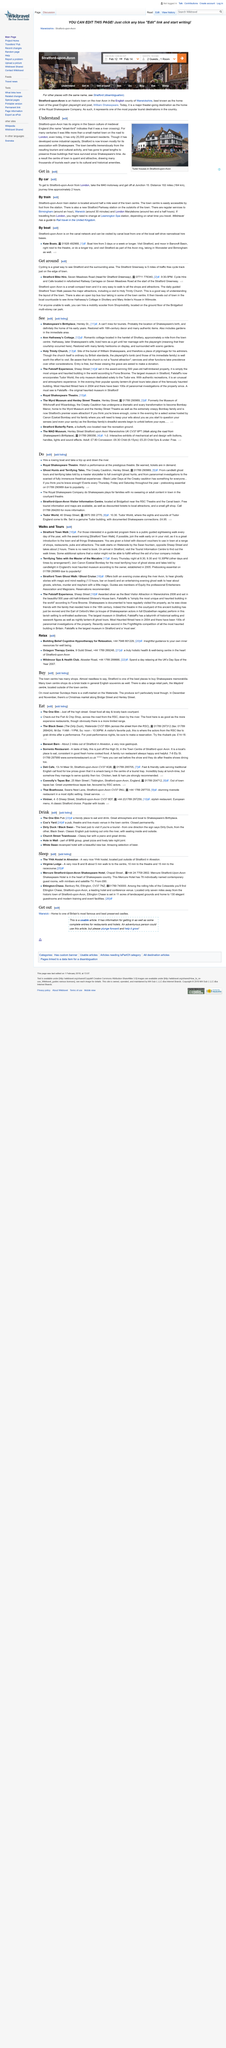Mention a couple of crucial points in this snapshot. Stratford-Upon-Avon is connected to other areas by a variety of transport links, including road, rail, and canal. These links enable people and goods to be transported efficiently and conveniently, making it an important hub for transportation in the region. It takes approximately 30 minutes by train to travel from Stratford-Upon-Avon to Warwick. At Holy Trinity Church, entry is free for visitors, but those who wish to view Shakespeare's grave are asked to make a donation. People who are unable to walk can get around by hiring a mobility scooter from Shopmobility. The distance between London and Stratford-Upon-Avon by road is 102 miles. 